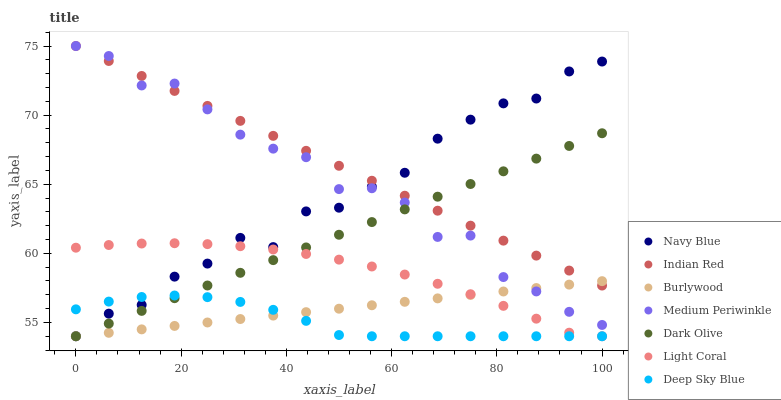Does Deep Sky Blue have the minimum area under the curve?
Answer yes or no. Yes. Does Indian Red have the maximum area under the curve?
Answer yes or no. Yes. Does Burlywood have the minimum area under the curve?
Answer yes or no. No. Does Burlywood have the maximum area under the curve?
Answer yes or no. No. Is Dark Olive the smoothest?
Answer yes or no. Yes. Is Medium Periwinkle the roughest?
Answer yes or no. Yes. Is Burlywood the smoothest?
Answer yes or no. No. Is Burlywood the roughest?
Answer yes or no. No. Does Deep Sky Blue have the lowest value?
Answer yes or no. Yes. Does Medium Periwinkle have the lowest value?
Answer yes or no. No. Does Indian Red have the highest value?
Answer yes or no. Yes. Does Burlywood have the highest value?
Answer yes or no. No. Is Deep Sky Blue less than Indian Red?
Answer yes or no. Yes. Is Indian Red greater than Light Coral?
Answer yes or no. Yes. Does Dark Olive intersect Medium Periwinkle?
Answer yes or no. Yes. Is Dark Olive less than Medium Periwinkle?
Answer yes or no. No. Is Dark Olive greater than Medium Periwinkle?
Answer yes or no. No. Does Deep Sky Blue intersect Indian Red?
Answer yes or no. No. 